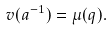Convert formula to latex. <formula><loc_0><loc_0><loc_500><loc_500>v ( a ^ { - 1 } ) = \mu ( q ) .</formula> 